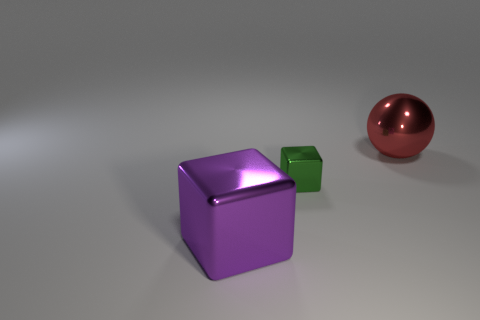Is there any indication of the size of these objects? Without a common reference object, it's difficult to determine the exact size. However, based on their appearance, they could be sized comparably to household items; the cubes may be similar in scale to dice or small boxes, and the sphere might be around the size of a standard ball. 